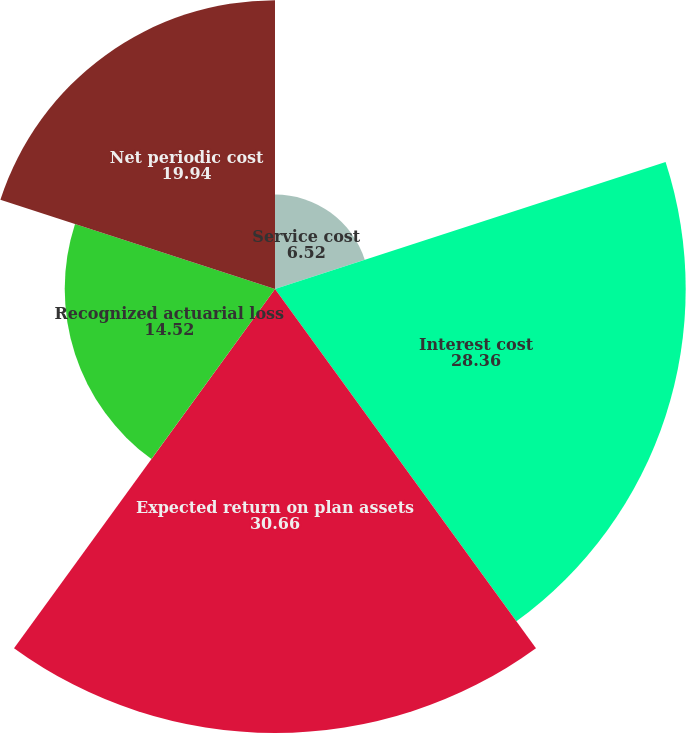Convert chart. <chart><loc_0><loc_0><loc_500><loc_500><pie_chart><fcel>Service cost<fcel>Interest cost<fcel>Expected return on plan assets<fcel>Recognized actuarial loss<fcel>Net periodic cost<nl><fcel>6.52%<fcel>28.36%<fcel>30.66%<fcel>14.52%<fcel>19.94%<nl></chart> 